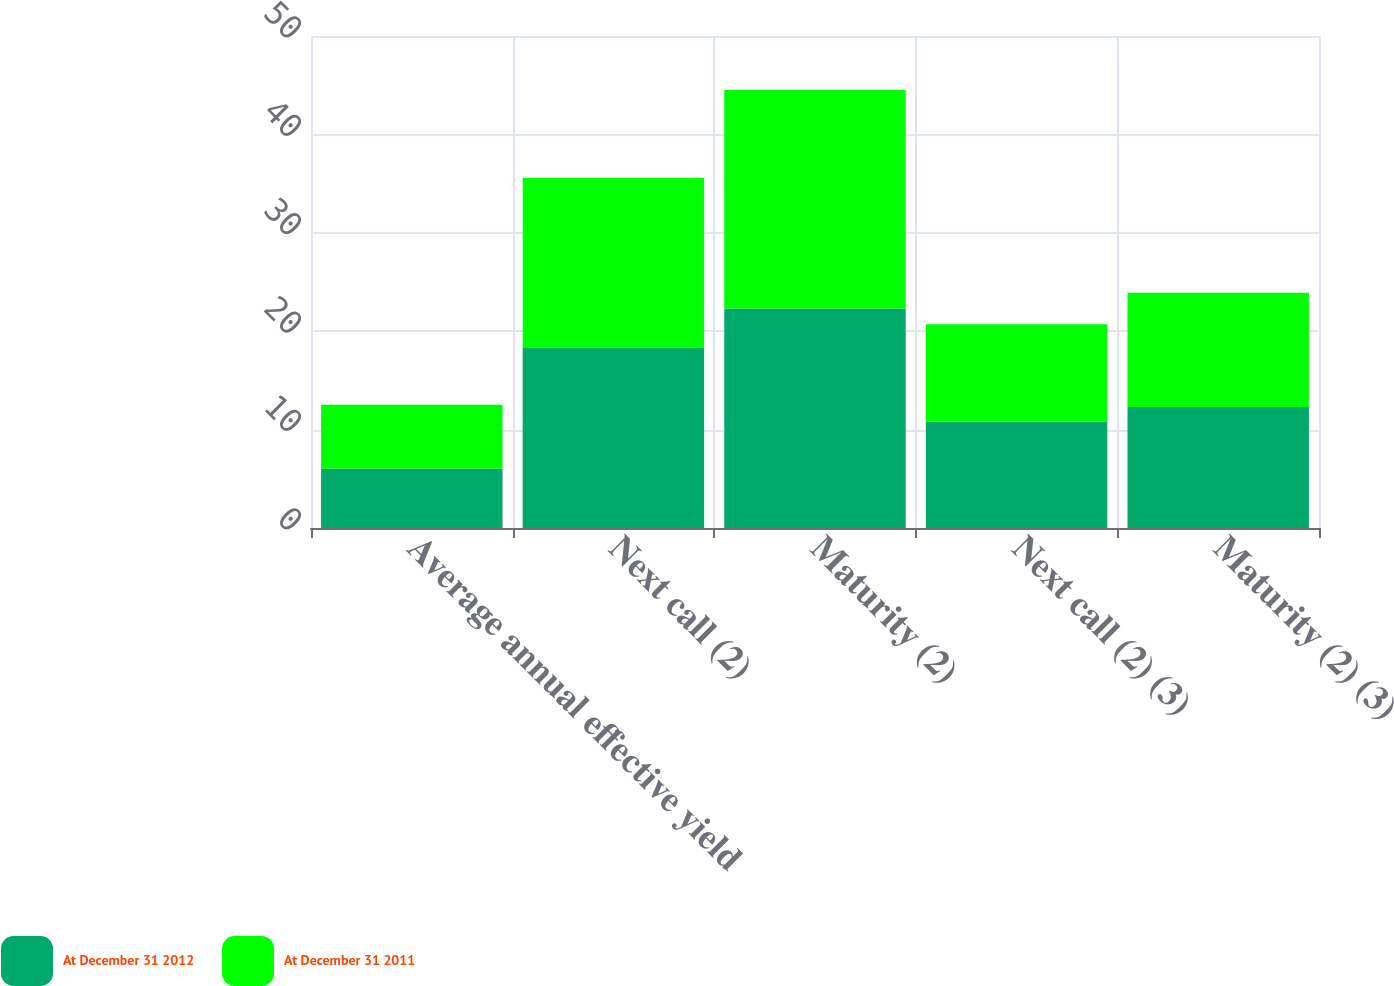<chart> <loc_0><loc_0><loc_500><loc_500><stacked_bar_chart><ecel><fcel>Average annual effective yield<fcel>Next call (2)<fcel>Maturity (2)<fcel>Next call (2) (3)<fcel>Maturity (2) (3)<nl><fcel>At December 31 2012<fcel>6.04<fcel>18.3<fcel>22.3<fcel>10.8<fcel>12.3<nl><fcel>At December 31 2011<fcel>6.49<fcel>17.3<fcel>22.2<fcel>9.9<fcel>11.6<nl></chart> 